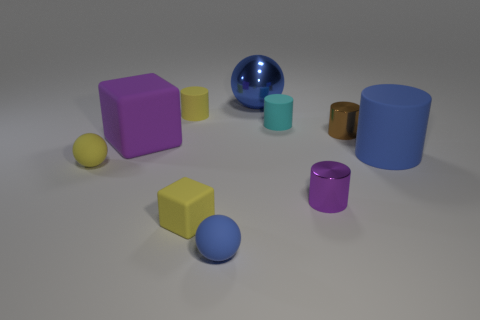What is the shape of the big thing that is to the right of the purple block and on the left side of the blue cylinder?
Give a very brief answer. Sphere. What number of other objects are the same shape as the blue metallic object?
Make the answer very short. 2. The brown object is what size?
Ensure brevity in your answer.  Small. How many things are small blue balls or large green cylinders?
Make the answer very short. 1. There is a rubber block that is in front of the purple matte cube; what size is it?
Your answer should be very brief. Small. Is there anything else that has the same size as the brown shiny cylinder?
Provide a succinct answer. Yes. What is the color of the small thing that is both in front of the small yellow matte cylinder and to the left of the yellow rubber block?
Make the answer very short. Yellow. Are the tiny cylinder that is on the left side of the large shiny ball and the big blue cylinder made of the same material?
Provide a short and direct response. Yes. Does the big metal object have the same color as the rubber block in front of the yellow ball?
Ensure brevity in your answer.  No. There is a tiny blue object; are there any large purple objects in front of it?
Offer a very short reply. No. 